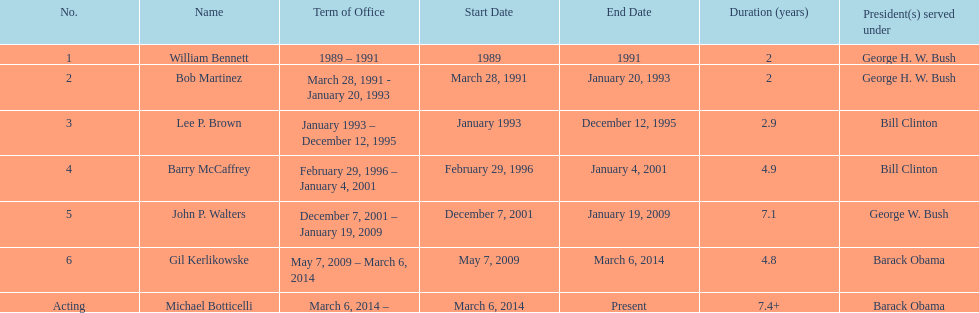Who serves inder barack obama? Gil Kerlikowske. 